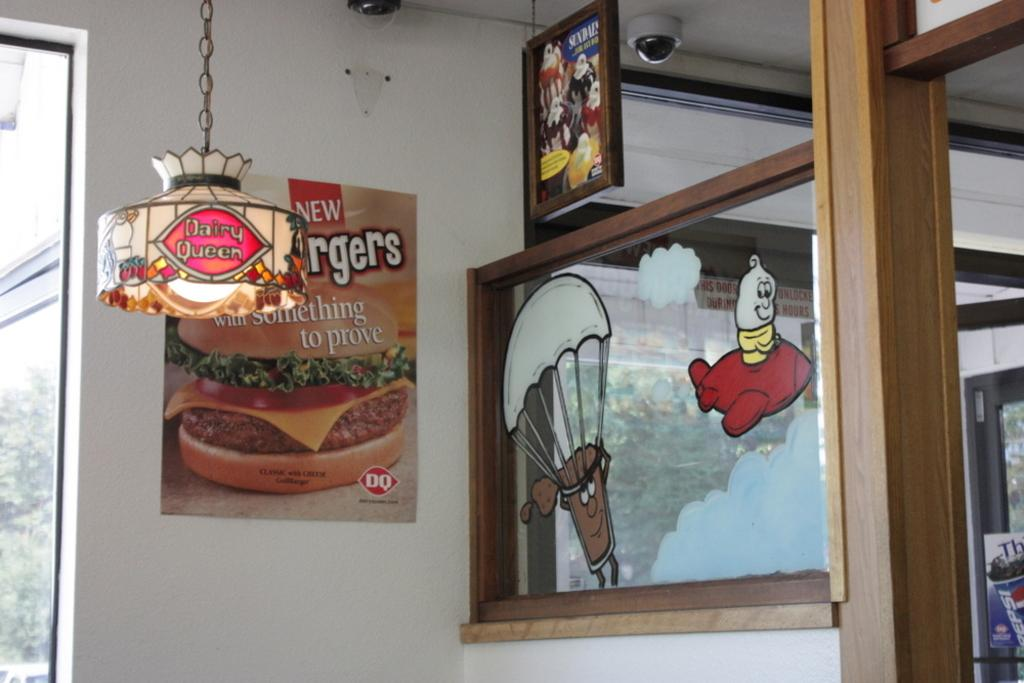What type of illumination is present in the image? There is a light in the image. What devices are used for capturing images in the image? There are cameras in the image. What is depicted on the glass in the image? There are paintings on the glass. What is hung on the wall in the image? There is a poster on the wall. What can be seen in the distance in the image? Trees are visible in the background of the image. What type of smell can be detected from the goat in the image? There is no goat present in the image, so no smell can be detected. What invention is being used to create the paintings on the glass in the image? The fact does not mention any specific invention used for creating the paintings on the glass, so we cannot determine that from the image. 